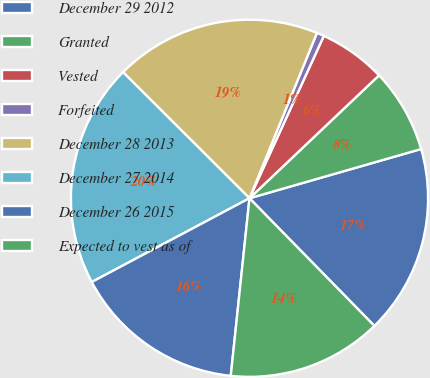Convert chart to OTSL. <chart><loc_0><loc_0><loc_500><loc_500><pie_chart><fcel>December 29 2012<fcel>Granted<fcel>Vested<fcel>Forfeited<fcel>December 28 2013<fcel>December 27 2014<fcel>December 26 2015<fcel>Expected to vest as of<nl><fcel>17.12%<fcel>7.64%<fcel>6.08%<fcel>0.67%<fcel>18.69%<fcel>20.25%<fcel>15.56%<fcel>14.0%<nl></chart> 